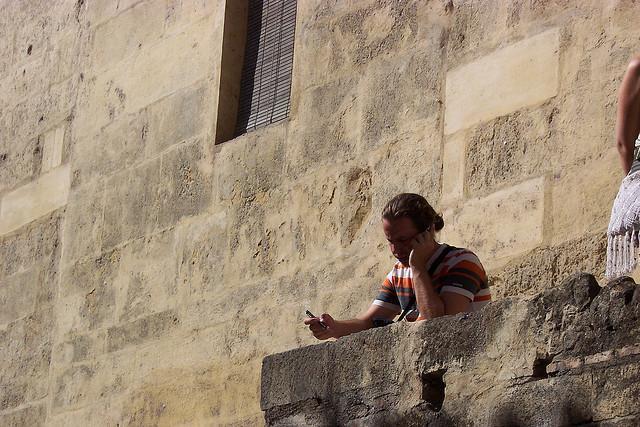How many people can be seen?
Give a very brief answer. 2. 